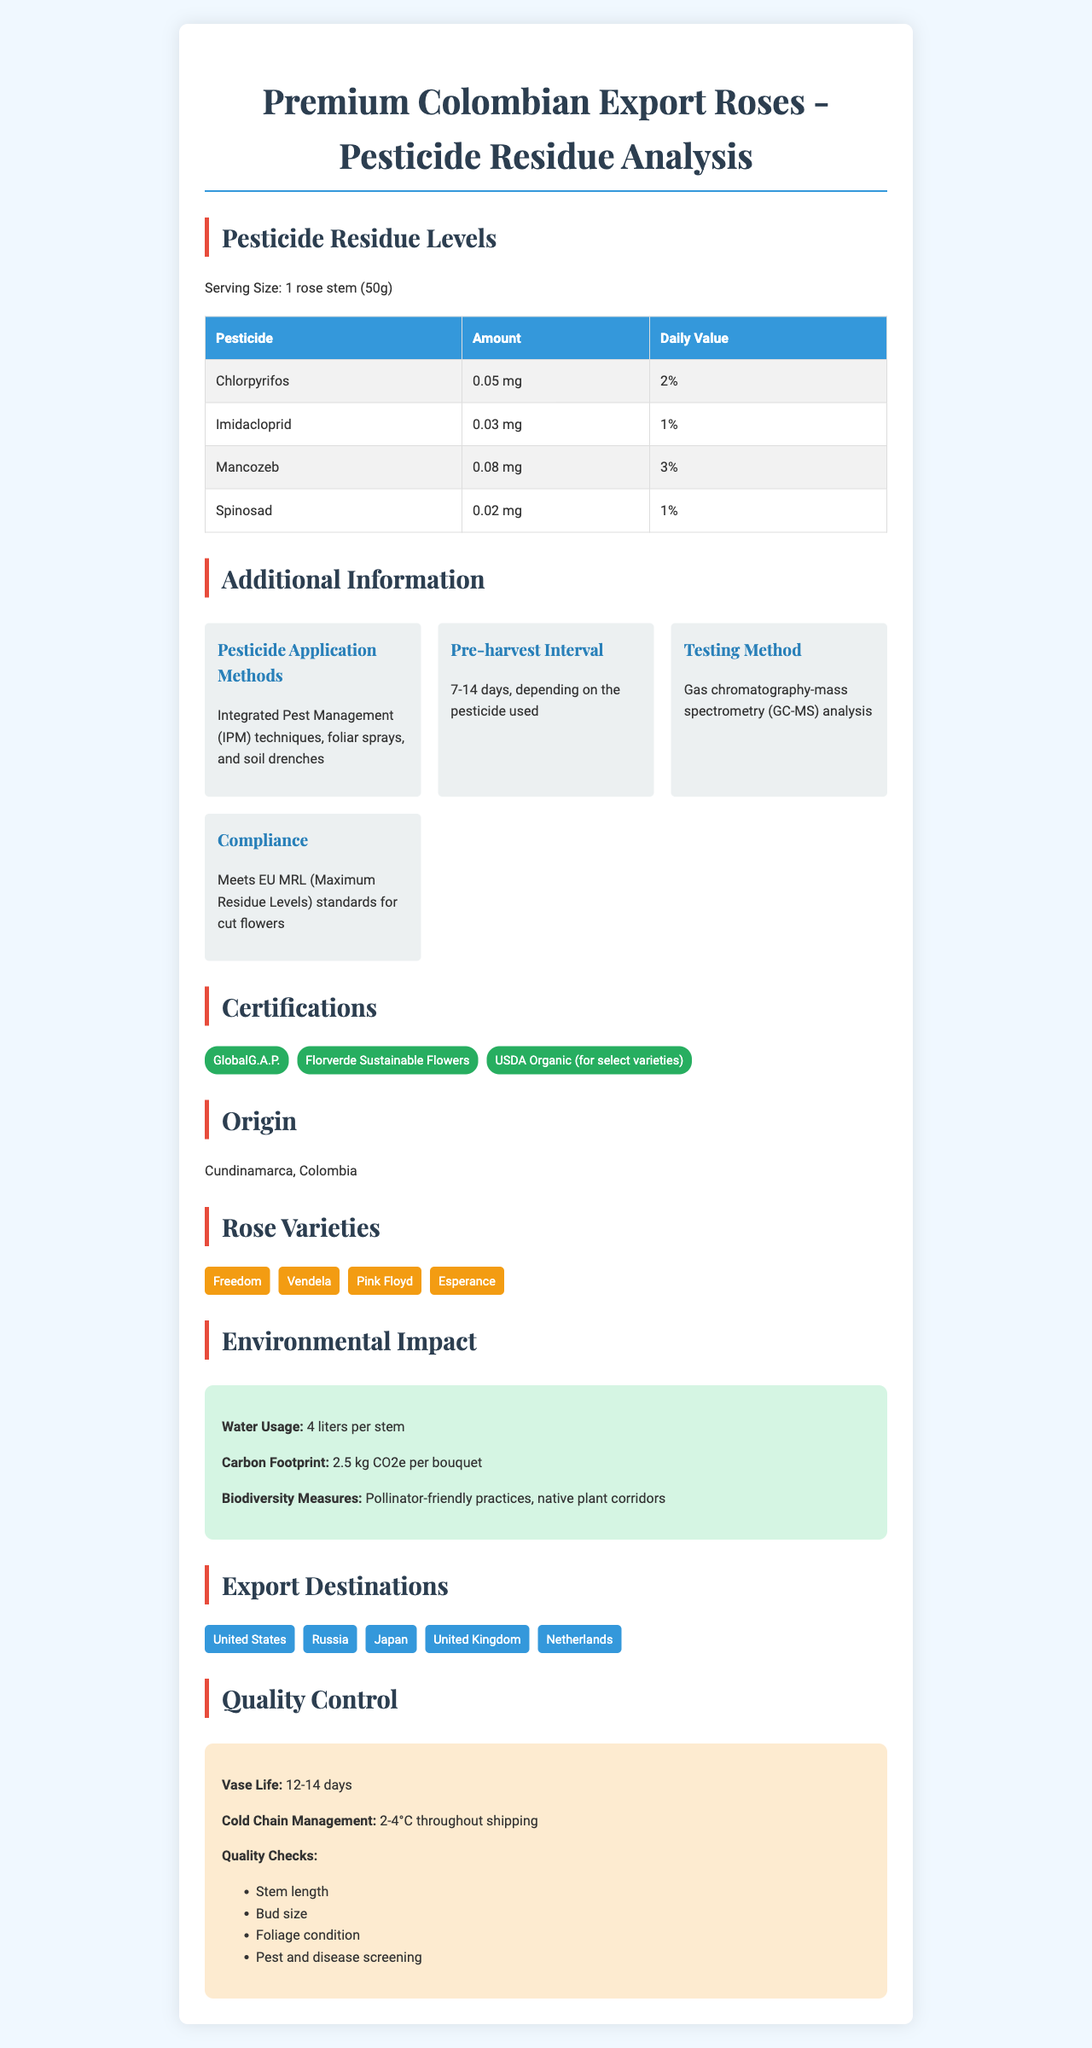what is the product name? The product name is prominently displayed at the top of the document.
Answer: Premium Colombian Export Roses what is the serving size for the pesticide residue analysis? The serving size is mentioned as "1 rose stem (50g)" under the Pesticide Residue Levels section.
Answer: 1 rose stem (50g) how much Chlorpyrifos residue is there per serving? The amount of Chlorpyrifos residue is listed as "0.05 mg" in the Pesticide Residue Levels table.
Answer: 0.05 mg what pesticide has the highest residue amount listed? Mancozeb has the highest residue amount listed at "0.08 mg" in the Pesticide Residue Levels table.
Answer: Mancozeb what is the pre-harvest interval for the pesticides used? The pre-harvest interval is given as "7-14 days, depending on the pesticide used" in the Additional Information section.
Answer: 7-14 days which pesticide contributes the most to the daily value percentage? Mancozeb contributes the most to the daily value at "3%" in the Pesticide Residue Levels table.
Answer: Mancozeb what analysis method is used for testing pesticide residues? The Testing Method in the Additional Information section states that GC-MS is used for analysis.
Answer: Gas chromatography-mass spectrometry (GC-MS) analysis which of the following certifications does not apply to all roses? A. GlobalG.A.P. B. Florverde Sustainable Flowers C. USDA Organic The certifications list includes "USDA Organic (for select varieties)" indicating it does not apply to all varieties.
Answer: C. USDA Organic which country is not listed as an export destination for the roses? A. United States B. Germany C. Japan D. Netherlands The listed export destinations include United States, Russia, Japan, United Kingdom, and Netherlands.
Answer: B. Germany true or false: the document states that all rose varieties are USDA Organic certified. Only "select varieties" are certified as USDA Organic according to the Certifications section.
Answer: False how would you summarize the document's main idea? The document includes various sections that offer insights into the product's pesticide analysis, certifications, origin, varieties, environmental impact, export destinations, and quality control.
Answer: The document provides detailed information on Premium Colombian Export Roses including pesticide residue levels, certifications, environmental impact, and quality control measures. what is the greenhouse gas emission per bouquet? The Environmental Impact section lists the carbon footprint as "2.5 kg CO2e per bouquet."
Answer: 2.5 kg CO2e per bouquet which of the following varieties is not mentioned in the document? A. Vendela B. Pink Floyd C. Blue Moon D. Esperance The varieties listed include Freedom, Vendela, Pink Floyd, and Esperance; Blue Moon is not mentioned.
Answer: C. Blue Moon where is the origin of these roses? The document specifies the origin as "Cundinamarca, Colombia."
Answer: Cundinamarca, Colombia how are the quality checks performed during control processes? The Quality Control section lists these categories for quality checks.
Answer: Stem length, Bud size, Foliage condition, Pest, and disease screening what is the cold chain management temperature range mentioned? The cold chain management is maintained at "2-4°C throughout shipping" according to the Quality Control section.
Answer: 2-4°C throughout shipping describe the environmental impact measures mentioned in the document. The environmental impact measures are outlined in the Environmental Impact section and include water usage, carbon footprint, and biodiversity measures.
Answer: The document mentions water usage of 4 liters per stem, a carbon footprint of 2.5 kg CO2e per bouquet, and biodiversity measures like pollinator-friendly practices and native plant corridors. is the gas chromatography-mass spectrometry (GC-MS) method always accurate? The document states that GC-MS is used for analysis but does not provide details on its accuracy or limitations.
Answer: Not enough information can we infer the exact shipping time from Colombia to the export destinations based on the document? The document does not provide specific information about the shipping time to the export destinations, only the cold chain management temperature range.
Answer: Cannot be determined 